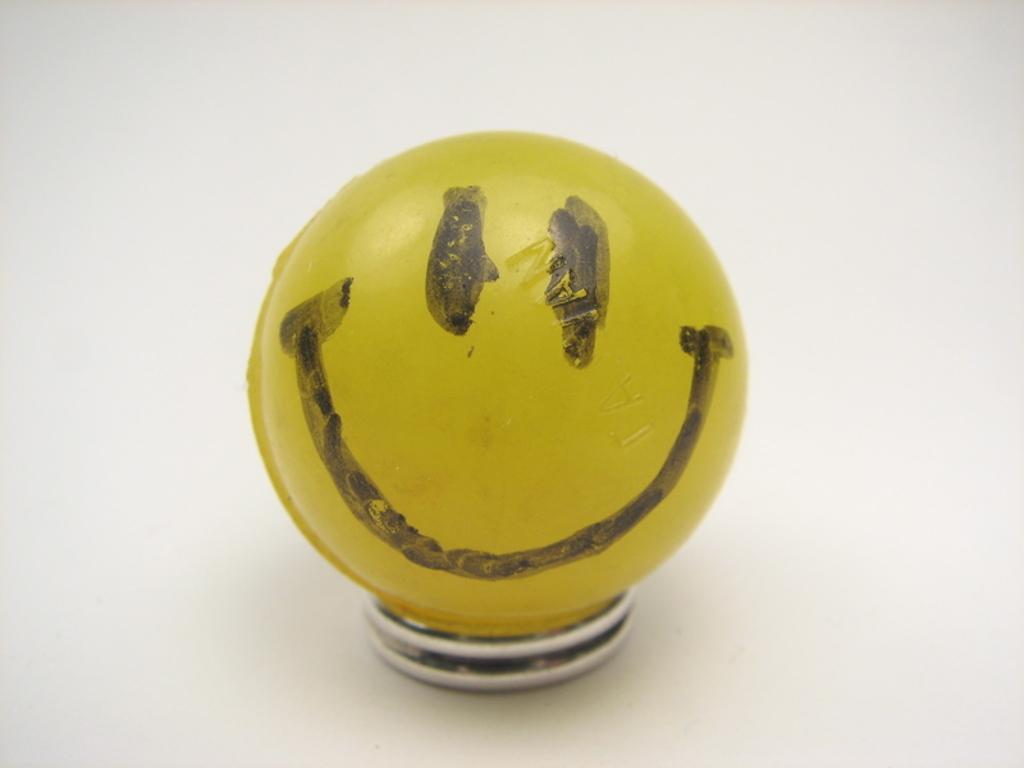How would you summarize this image in a sentence or two? Here we can see a yellow color ball with a smiley face symbol on it on an object on a platform. 